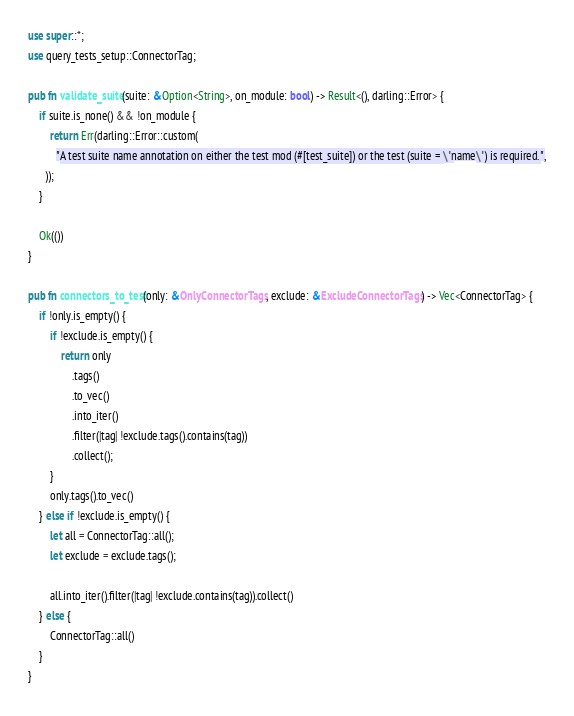<code> <loc_0><loc_0><loc_500><loc_500><_Rust_>use super::*;
use query_tests_setup::ConnectorTag;

pub fn validate_suite(suite: &Option<String>, on_module: bool) -> Result<(), darling::Error> {
    if suite.is_none() && !on_module {
        return Err(darling::Error::custom(
          "A test suite name annotation on either the test mod (#[test_suite]) or the test (suite = \"name\") is required.",
      ));
    }

    Ok(())
}

pub fn connectors_to_test(only: &OnlyConnectorTags, exclude: &ExcludeConnectorTags) -> Vec<ConnectorTag> {
    if !only.is_empty() {
        if !exclude.is_empty() {
            return only
                .tags()
                .to_vec()
                .into_iter()
                .filter(|tag| !exclude.tags().contains(tag))
                .collect();
        }
        only.tags().to_vec()
    } else if !exclude.is_empty() {
        let all = ConnectorTag::all();
        let exclude = exclude.tags();

        all.into_iter().filter(|tag| !exclude.contains(tag)).collect()
    } else {
        ConnectorTag::all()
    }
}
</code> 